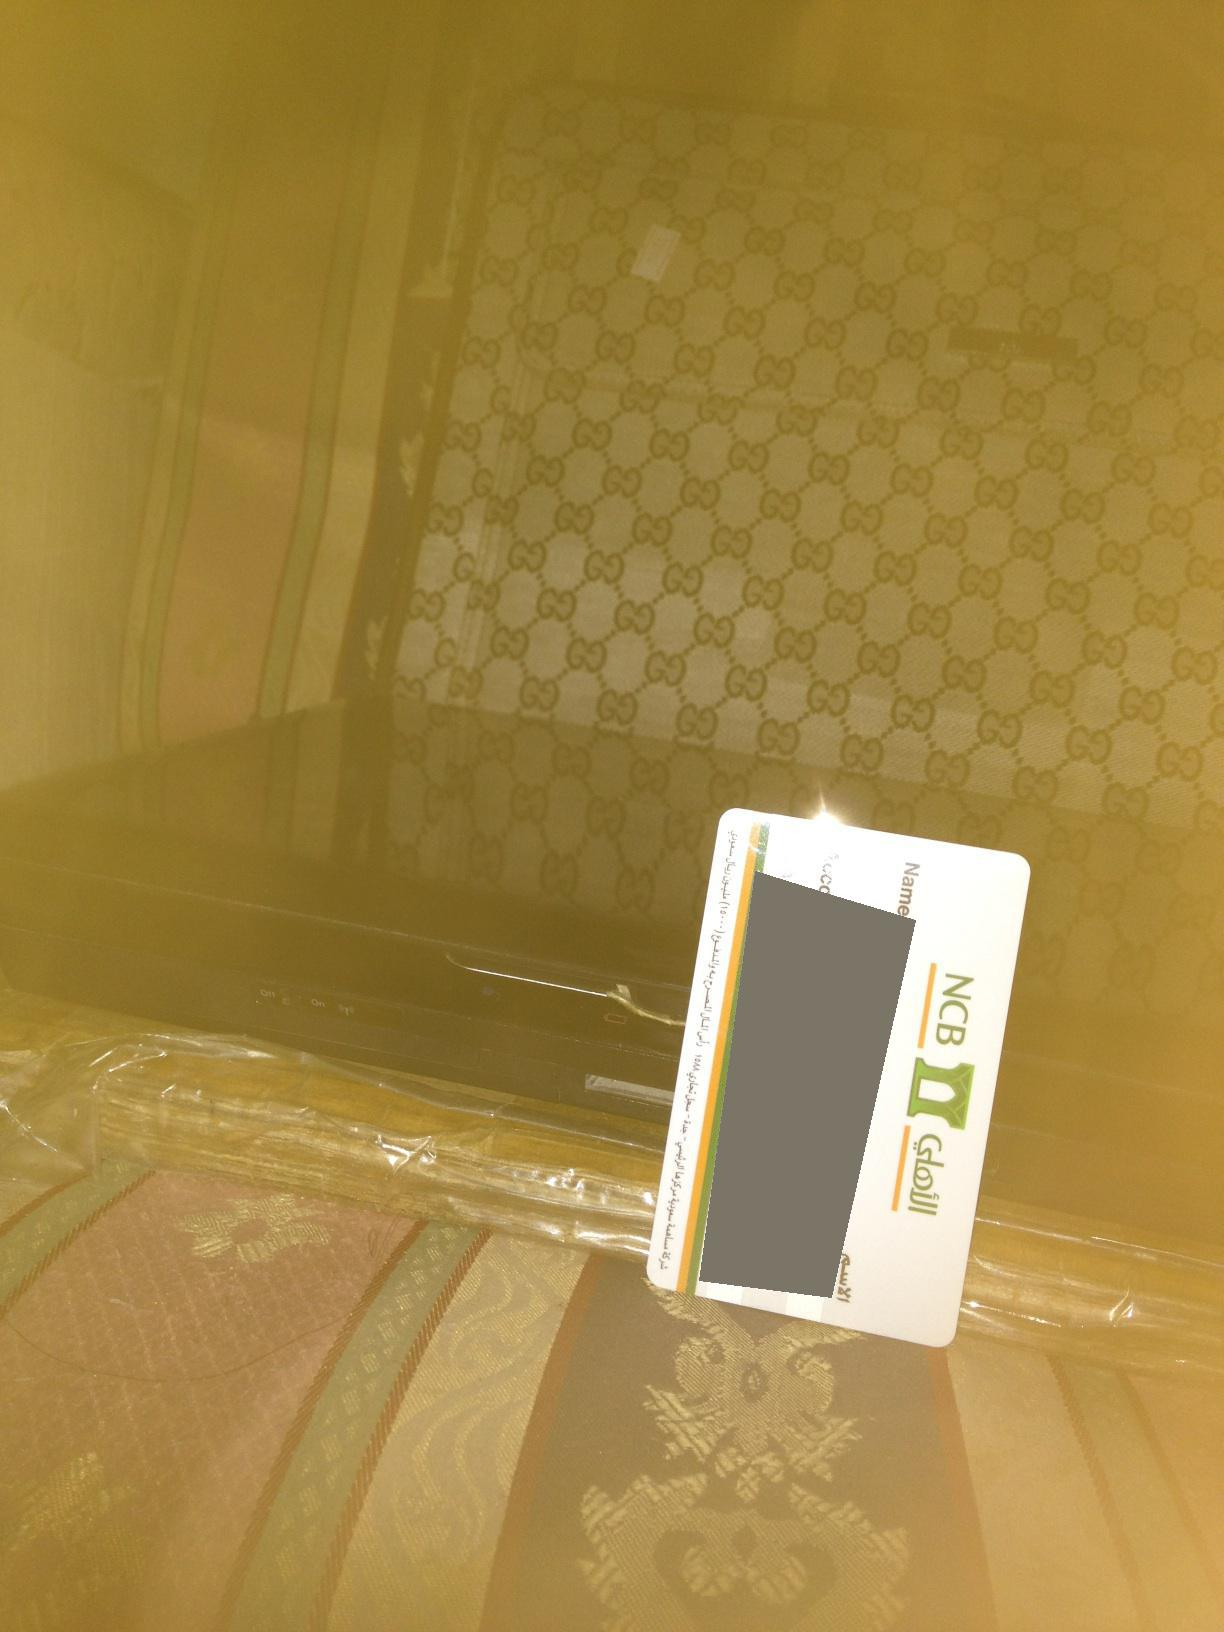What are the objects present in the image? The image features a patterned suitcase, a credit card placed on it, and some sort of electronic device beneath a transparent plastic cover. The patterned suitcase has a distinct design that could be associated with a specific brand. 